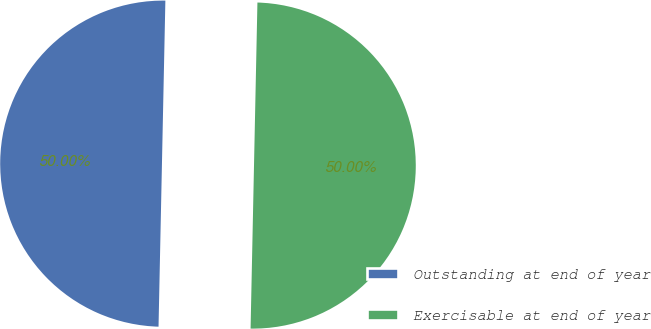<chart> <loc_0><loc_0><loc_500><loc_500><pie_chart><fcel>Outstanding at end of year<fcel>Exercisable at end of year<nl><fcel>50.0%<fcel>50.0%<nl></chart> 